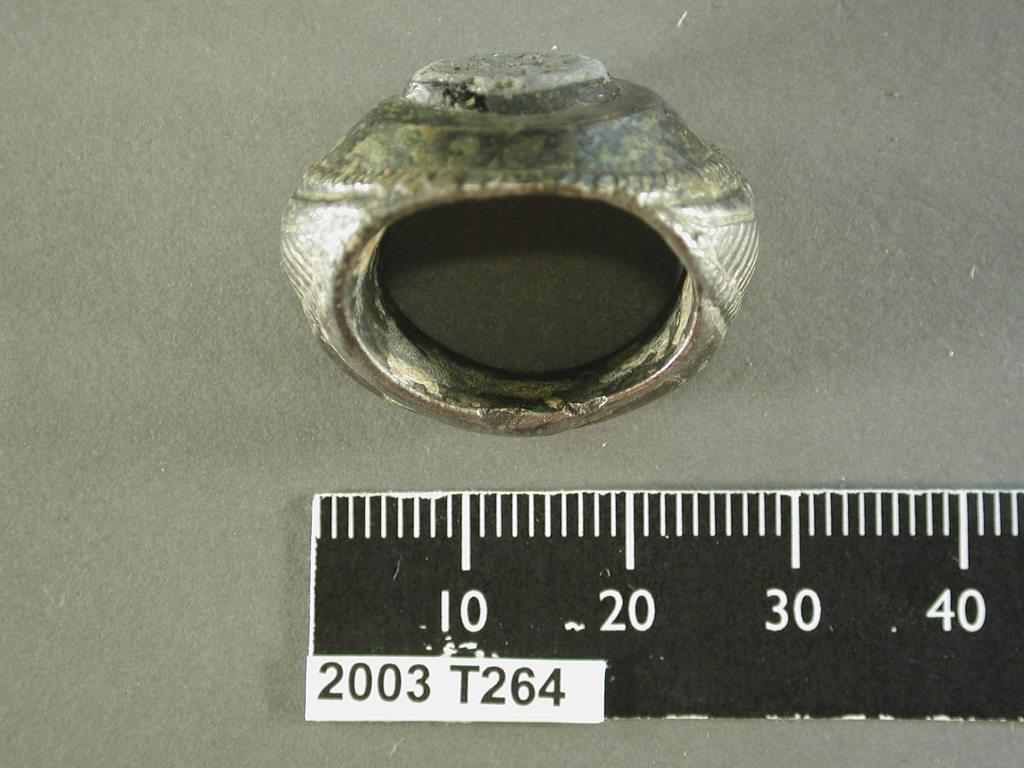<image>
Present a compact description of the photo's key features. An old ring sits next to a ruler that says 2003 T264. 